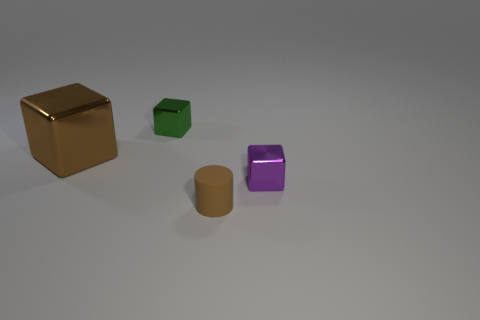Add 3 small brown cylinders. How many objects exist? 7 Subtract all blocks. How many objects are left? 1 Add 1 small green metal cubes. How many small green metal cubes exist? 2 Subtract 1 purple blocks. How many objects are left? 3 Subtract all big red balls. Subtract all small green shiny blocks. How many objects are left? 3 Add 1 tiny purple metallic blocks. How many tiny purple metallic blocks are left? 2 